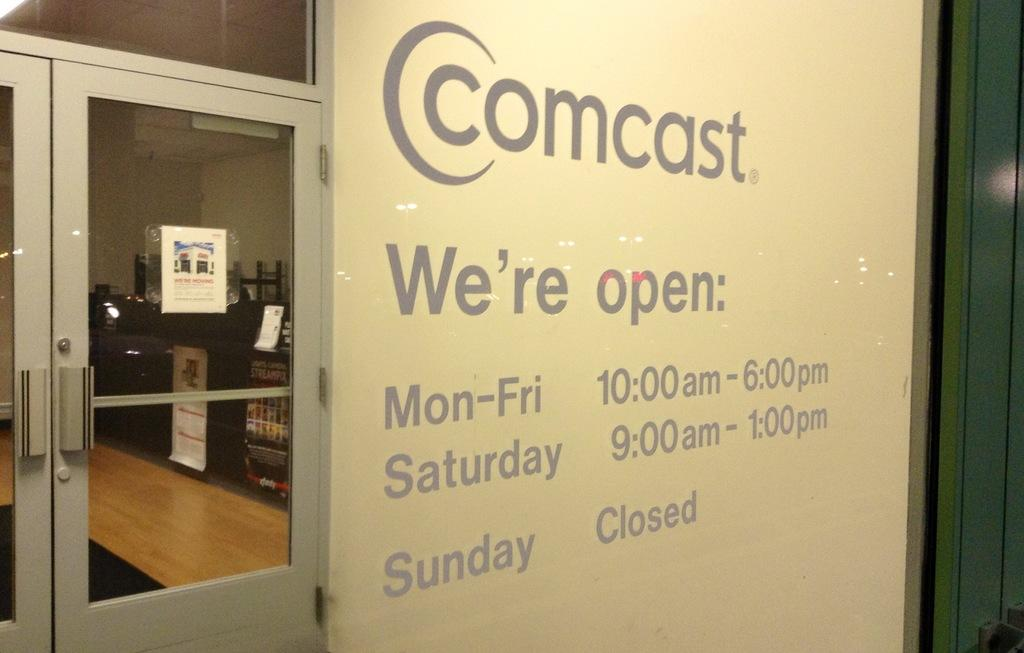What is located in the center of the image? There is a wall in the center of the image. Where is the door situated in relation to the wall? The door is on the right side of the image. What can be seen through the door's glass? Tables are visible through the glass of the door. What type of instrument is being played on the floor in the image? There is no instrument or floor visible in the image; it only features a wall and a door. 